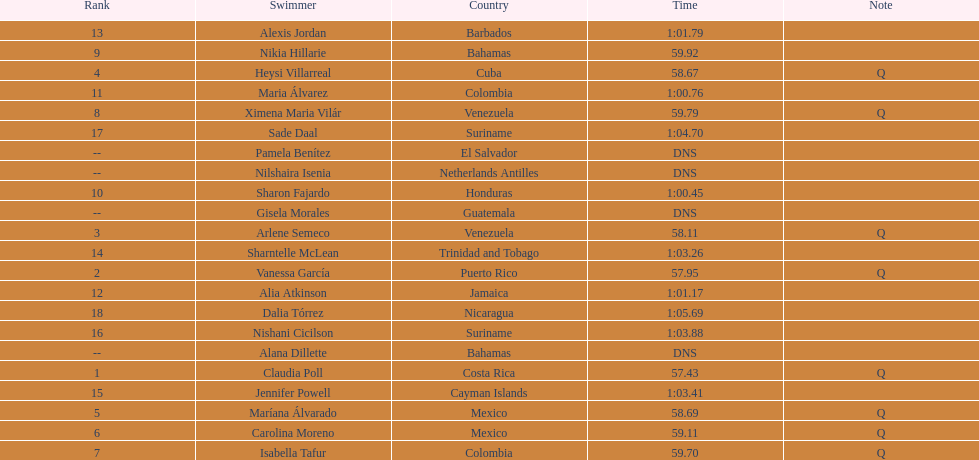How many mexican swimmers ranked in the top 10? 2. 